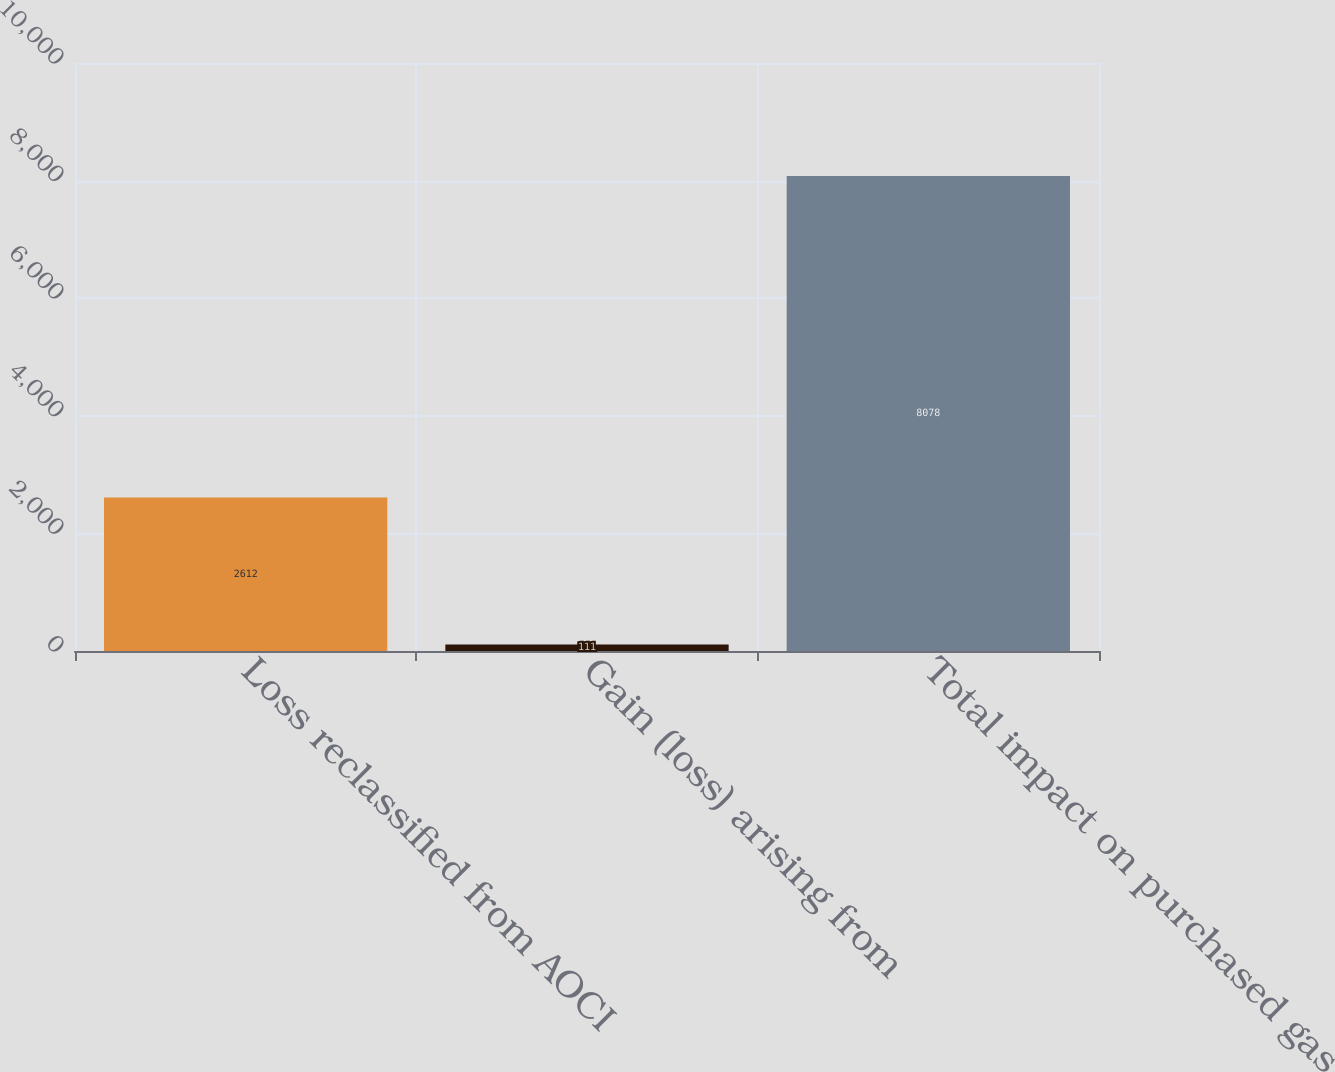Convert chart to OTSL. <chart><loc_0><loc_0><loc_500><loc_500><bar_chart><fcel>Loss reclassified from AOCI<fcel>Gain (loss) arising from<fcel>Total impact on purchased gas<nl><fcel>2612<fcel>111<fcel>8078<nl></chart> 